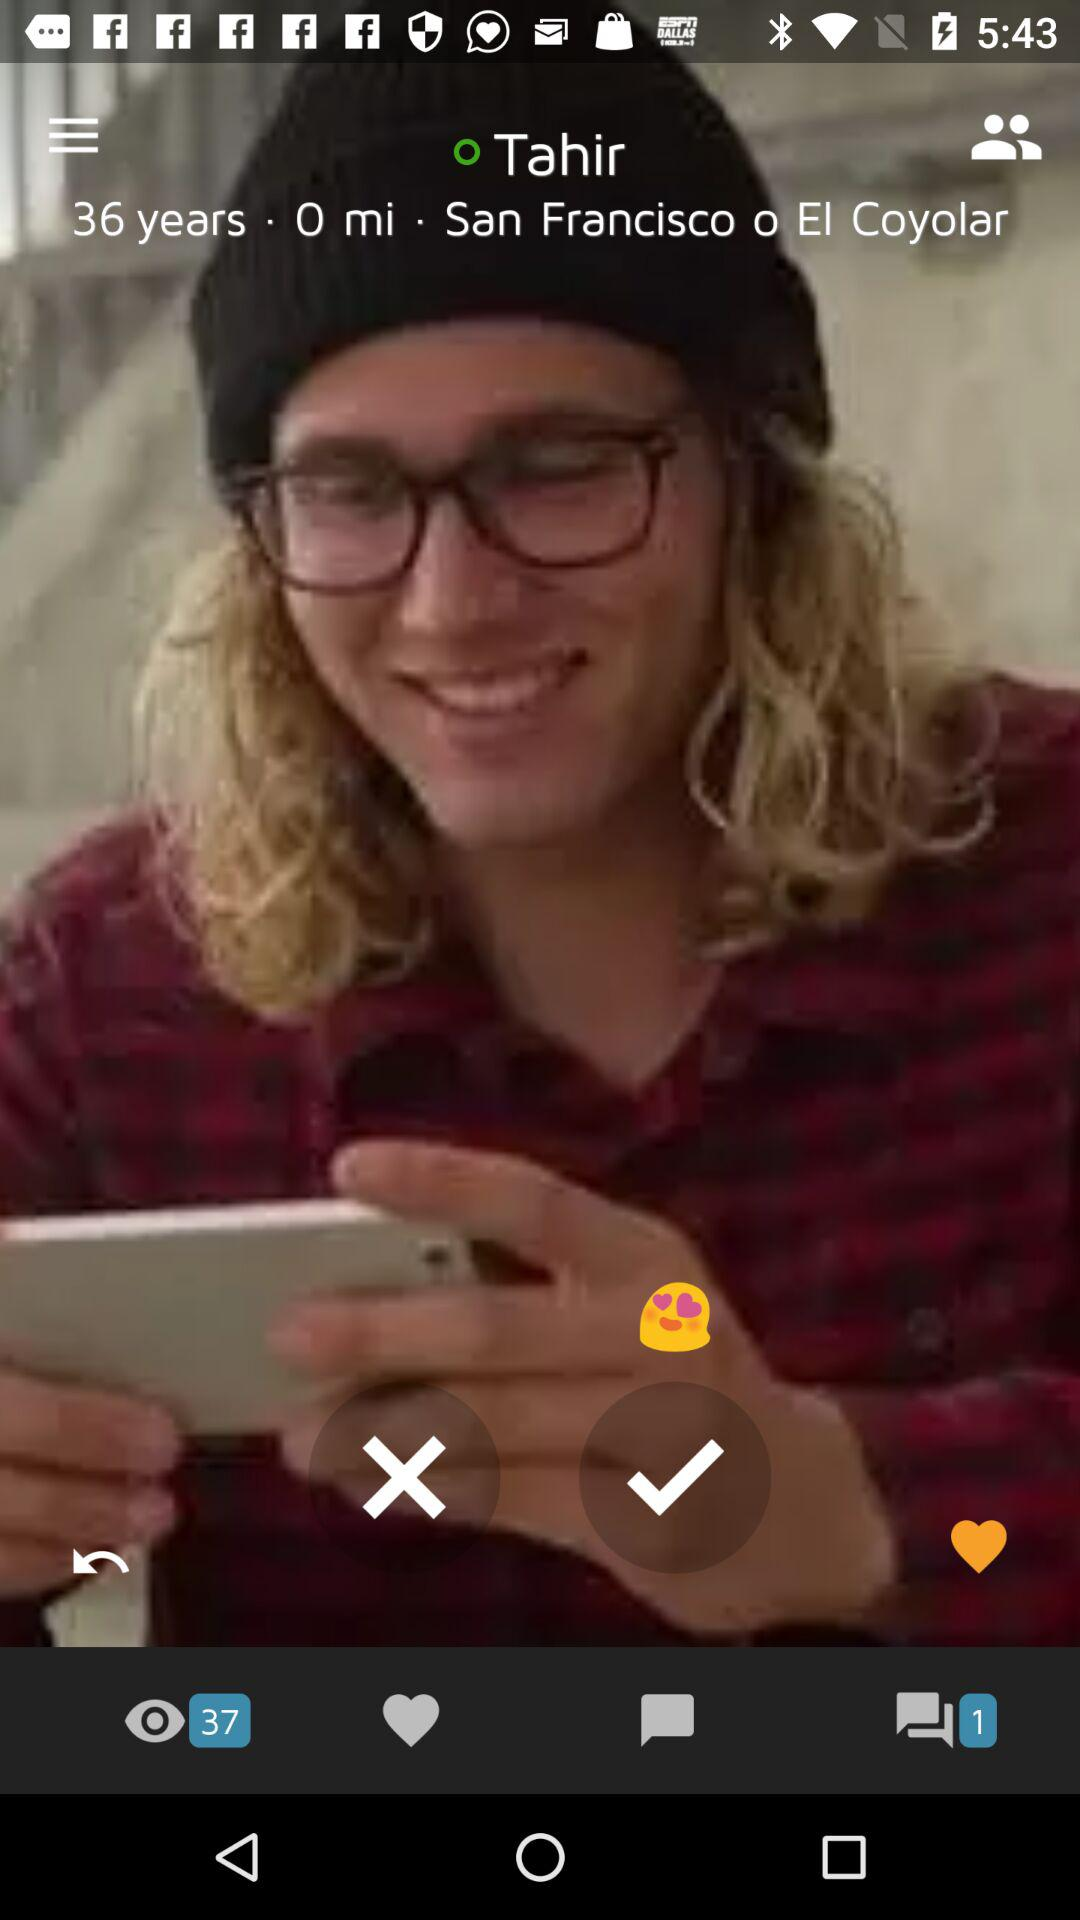How many people viewed Tahir's profile? The people who viewed Tahir's profile are 37. 